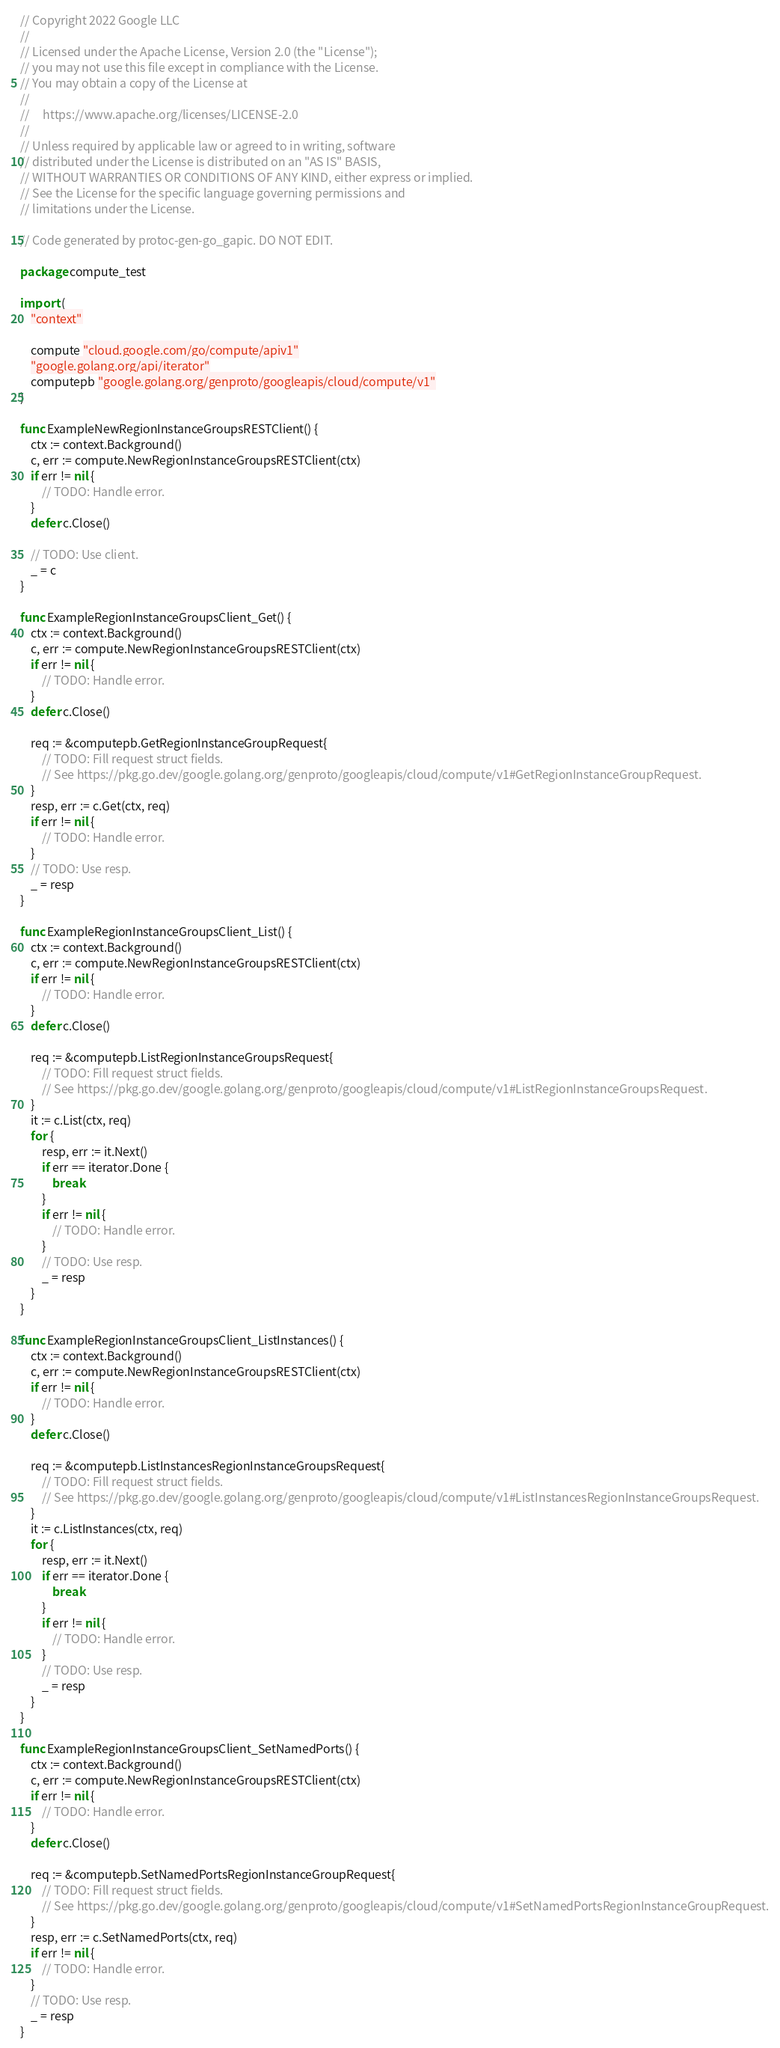<code> <loc_0><loc_0><loc_500><loc_500><_Go_>// Copyright 2022 Google LLC
//
// Licensed under the Apache License, Version 2.0 (the "License");
// you may not use this file except in compliance with the License.
// You may obtain a copy of the License at
//
//     https://www.apache.org/licenses/LICENSE-2.0
//
// Unless required by applicable law or agreed to in writing, software
// distributed under the License is distributed on an "AS IS" BASIS,
// WITHOUT WARRANTIES OR CONDITIONS OF ANY KIND, either express or implied.
// See the License for the specific language governing permissions and
// limitations under the License.

// Code generated by protoc-gen-go_gapic. DO NOT EDIT.

package compute_test

import (
	"context"

	compute "cloud.google.com/go/compute/apiv1"
	"google.golang.org/api/iterator"
	computepb "google.golang.org/genproto/googleapis/cloud/compute/v1"
)

func ExampleNewRegionInstanceGroupsRESTClient() {
	ctx := context.Background()
	c, err := compute.NewRegionInstanceGroupsRESTClient(ctx)
	if err != nil {
		// TODO: Handle error.
	}
	defer c.Close()

	// TODO: Use client.
	_ = c
}

func ExampleRegionInstanceGroupsClient_Get() {
	ctx := context.Background()
	c, err := compute.NewRegionInstanceGroupsRESTClient(ctx)
	if err != nil {
		// TODO: Handle error.
	}
	defer c.Close()

	req := &computepb.GetRegionInstanceGroupRequest{
		// TODO: Fill request struct fields.
		// See https://pkg.go.dev/google.golang.org/genproto/googleapis/cloud/compute/v1#GetRegionInstanceGroupRequest.
	}
	resp, err := c.Get(ctx, req)
	if err != nil {
		// TODO: Handle error.
	}
	// TODO: Use resp.
	_ = resp
}

func ExampleRegionInstanceGroupsClient_List() {
	ctx := context.Background()
	c, err := compute.NewRegionInstanceGroupsRESTClient(ctx)
	if err != nil {
		// TODO: Handle error.
	}
	defer c.Close()

	req := &computepb.ListRegionInstanceGroupsRequest{
		// TODO: Fill request struct fields.
		// See https://pkg.go.dev/google.golang.org/genproto/googleapis/cloud/compute/v1#ListRegionInstanceGroupsRequest.
	}
	it := c.List(ctx, req)
	for {
		resp, err := it.Next()
		if err == iterator.Done {
			break
		}
		if err != nil {
			// TODO: Handle error.
		}
		// TODO: Use resp.
		_ = resp
	}
}

func ExampleRegionInstanceGroupsClient_ListInstances() {
	ctx := context.Background()
	c, err := compute.NewRegionInstanceGroupsRESTClient(ctx)
	if err != nil {
		// TODO: Handle error.
	}
	defer c.Close()

	req := &computepb.ListInstancesRegionInstanceGroupsRequest{
		// TODO: Fill request struct fields.
		// See https://pkg.go.dev/google.golang.org/genproto/googleapis/cloud/compute/v1#ListInstancesRegionInstanceGroupsRequest.
	}
	it := c.ListInstances(ctx, req)
	for {
		resp, err := it.Next()
		if err == iterator.Done {
			break
		}
		if err != nil {
			// TODO: Handle error.
		}
		// TODO: Use resp.
		_ = resp
	}
}

func ExampleRegionInstanceGroupsClient_SetNamedPorts() {
	ctx := context.Background()
	c, err := compute.NewRegionInstanceGroupsRESTClient(ctx)
	if err != nil {
		// TODO: Handle error.
	}
	defer c.Close()

	req := &computepb.SetNamedPortsRegionInstanceGroupRequest{
		// TODO: Fill request struct fields.
		// See https://pkg.go.dev/google.golang.org/genproto/googleapis/cloud/compute/v1#SetNamedPortsRegionInstanceGroupRequest.
	}
	resp, err := c.SetNamedPorts(ctx, req)
	if err != nil {
		// TODO: Handle error.
	}
	// TODO: Use resp.
	_ = resp
}
</code> 